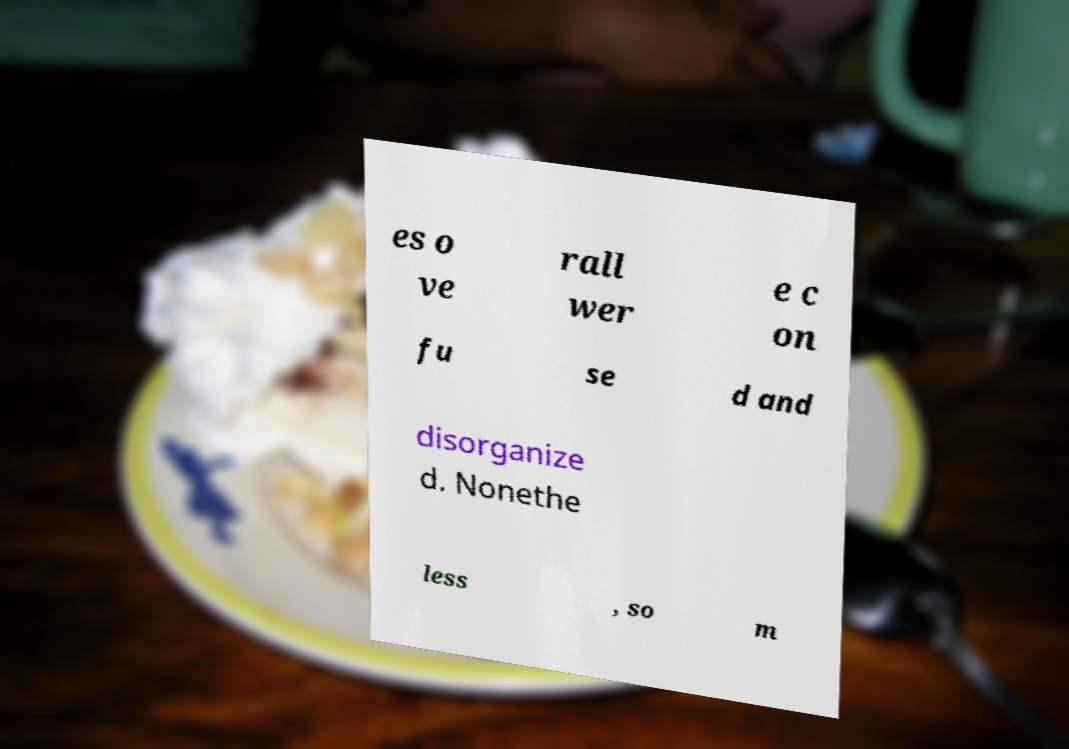What messages or text are displayed in this image? I need them in a readable, typed format. es o ve rall wer e c on fu se d and disorganize d. Nonethe less , so m 